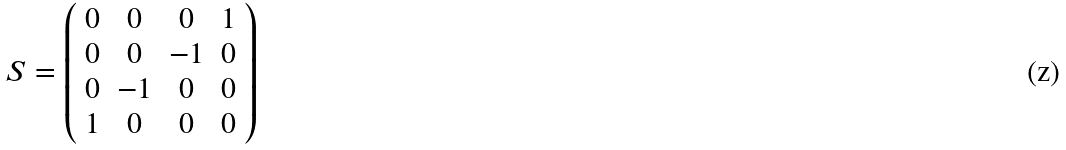Convert formula to latex. <formula><loc_0><loc_0><loc_500><loc_500>S = \left ( \begin{array} { c c c c } 0 & 0 & 0 & 1 \\ 0 & 0 & - 1 & 0 \\ 0 & - 1 & 0 & 0 \\ 1 & 0 & 0 & 0 \\ \end{array} \right )</formula> 